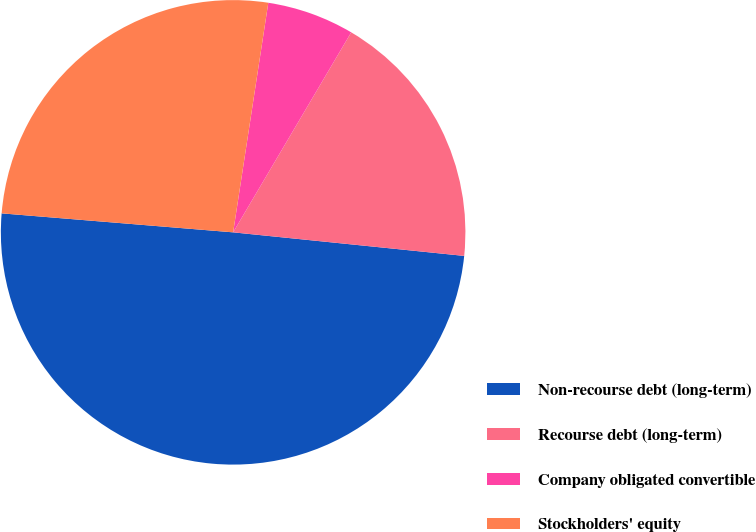Convert chart to OTSL. <chart><loc_0><loc_0><loc_500><loc_500><pie_chart><fcel>Non-recourse debt (long-term)<fcel>Recourse debt (long-term)<fcel>Company obligated convertible<fcel>Stockholders' equity<nl><fcel>49.69%<fcel>18.13%<fcel>6.07%<fcel>26.12%<nl></chart> 